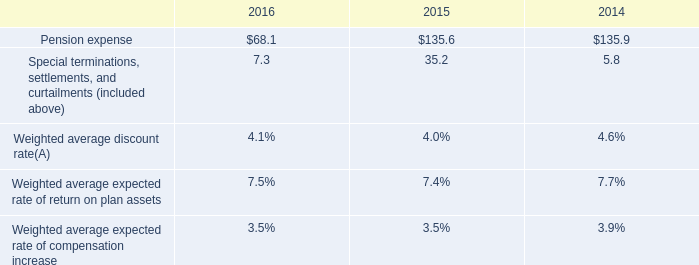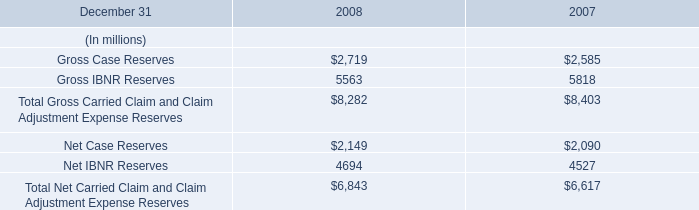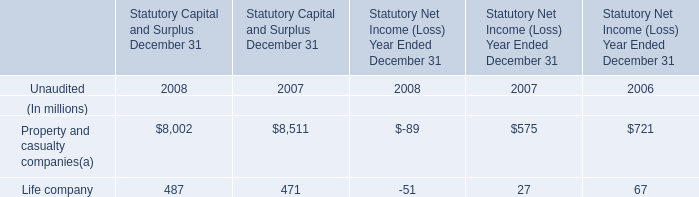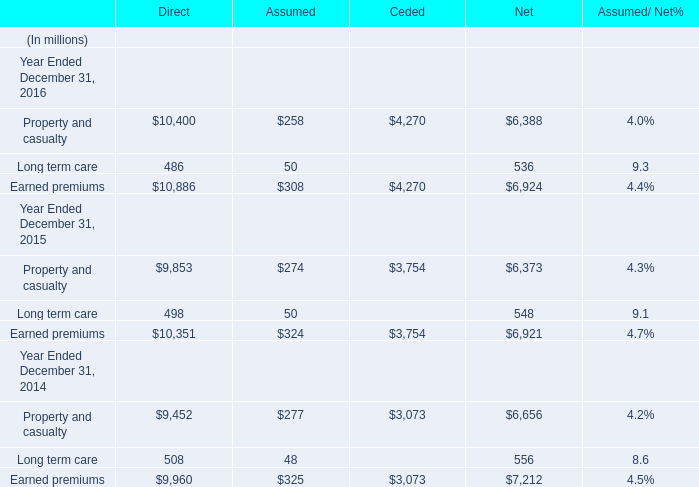considering the 2016's special terminations settlements and curtailments , what is the percentage of pension settlement losses concerning the total value? 
Computations: (6.4 / 7.3)
Answer: 0.87671. 